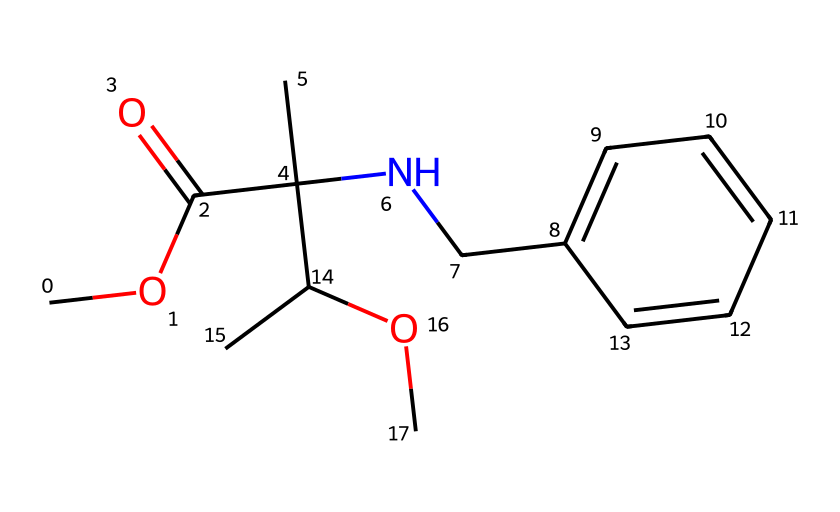What is the molecular formula of metalaxyl? To determine the molecular formula, we count all the atoms present in the SMILES representation. The formula includes carbon (C), hydrogen (H), oxygen (O), and nitrogen (N). Counting gives us C12, H17, N, 2, O2.
Answer: C12H17N2O2 How many carbon atoms are in this structure? By examining the SMILES representation, we identify each 'C' character, including those in branches and chains. There are 12 carbon atoms.
Answer: 12 What functional groups are present in metalaxyl? The SMILES shows an ester (COC(=O)), an amine (NCC), and ether groups (C(C)OC). These groups determine its reactivity and interactions.
Answer: ester, amine, ether Is metalaxyl a systemic fungicide? Yes, according to the classification of fungicides, metalaxyl is designed to be absorbed by plants, making it systemic.
Answer: Yes What is the primary nitrogen atom's role in metalaxyl? The nitrogen atom in the structure is part of an amine group, which is important for its biological activity and effectiveness as a fungicide.
Answer: biological activity What type of bonding is likely prominent in metalaxyl? Given the presence of carbon chains and functional groups, covalent bonding is predominant for metalaxyl, as it forms stable connections with other atoms.
Answer: covalent What kind of interactions would metalaxyl have in the environment? Due to its functional groups, it would likely engage in hydrogen bonding and hydrophobic interactions, influencing its behavior in soil and water.
Answer: hydrogen bonding, hydrophobic interactions 